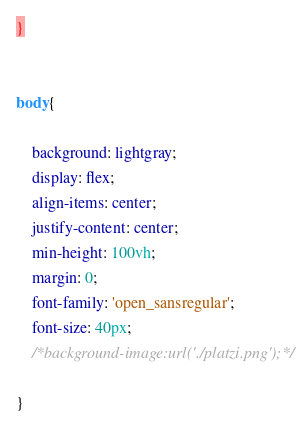Convert code to text. <code><loc_0><loc_0><loc_500><loc_500><_CSS_>}


body{

	background: lightgray;
	display: flex;
	align-items: center;
	justify-content: center;
	min-height: 100vh;
	margin: 0;
	font-family: 'open_sansregular';
	font-size: 40px;
	/*background-image:url('./platzi.png');*/
	
}</code> 